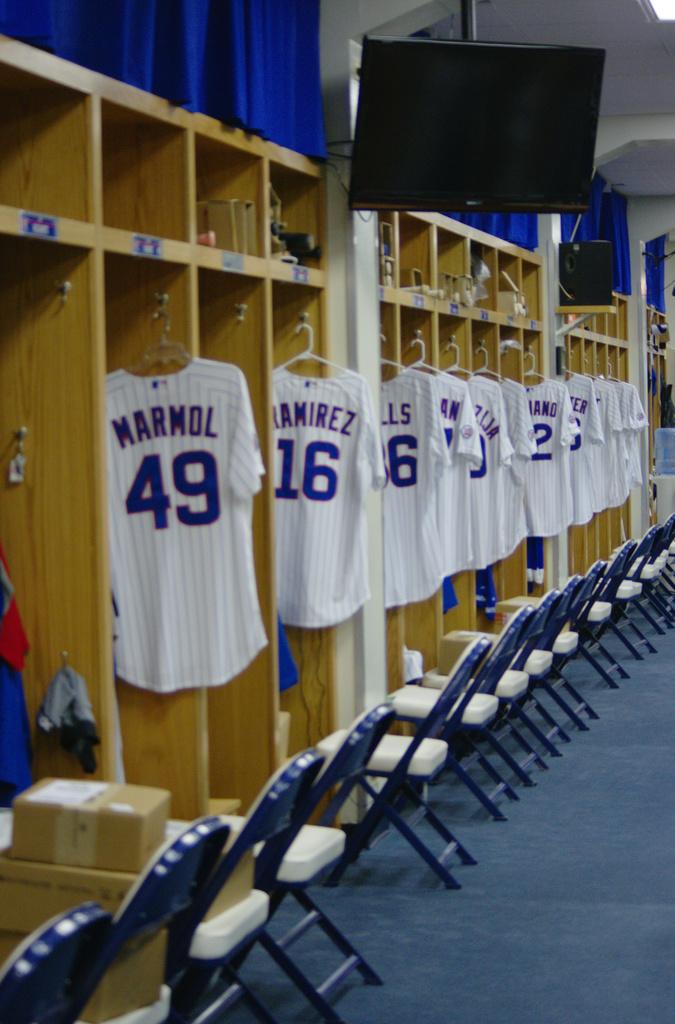What name is on the shirt closest to the camera?
Your answer should be very brief. Marmol. 